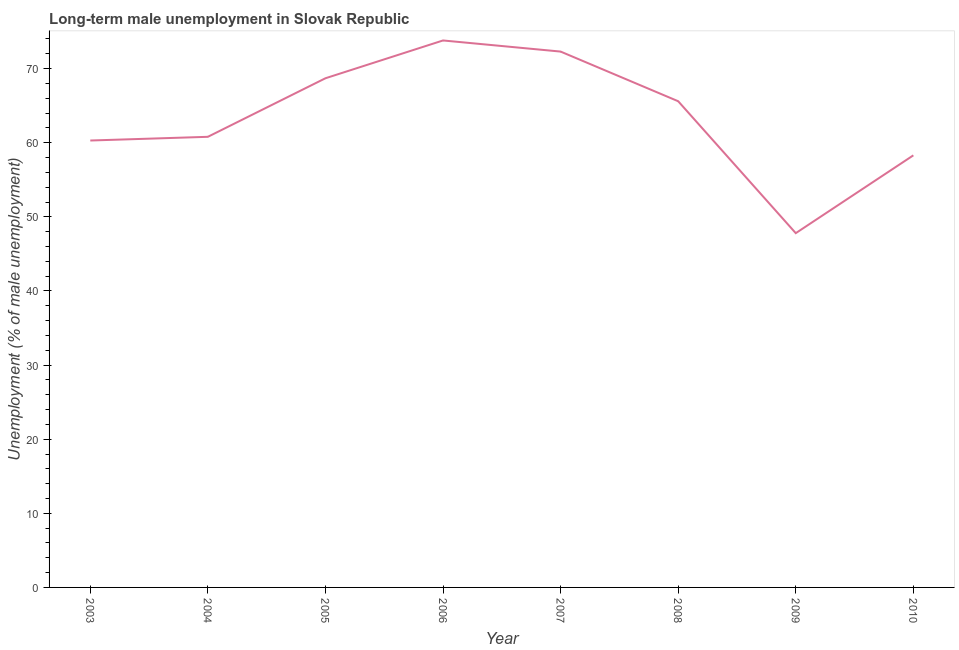What is the long-term male unemployment in 2008?
Provide a short and direct response. 65.6. Across all years, what is the maximum long-term male unemployment?
Provide a succinct answer. 73.8. Across all years, what is the minimum long-term male unemployment?
Your answer should be very brief. 47.8. In which year was the long-term male unemployment maximum?
Your response must be concise. 2006. In which year was the long-term male unemployment minimum?
Provide a short and direct response. 2009. What is the sum of the long-term male unemployment?
Provide a short and direct response. 507.6. What is the difference between the long-term male unemployment in 2004 and 2008?
Your answer should be very brief. -4.8. What is the average long-term male unemployment per year?
Keep it short and to the point. 63.45. What is the median long-term male unemployment?
Your response must be concise. 63.2. What is the ratio of the long-term male unemployment in 2005 to that in 2007?
Ensure brevity in your answer.  0.95. Is the long-term male unemployment in 2008 less than that in 2009?
Your answer should be compact. No. Is the sum of the long-term male unemployment in 2006 and 2008 greater than the maximum long-term male unemployment across all years?
Provide a succinct answer. Yes. What is the difference between the highest and the lowest long-term male unemployment?
Ensure brevity in your answer.  26. In how many years, is the long-term male unemployment greater than the average long-term male unemployment taken over all years?
Provide a short and direct response. 4. How many lines are there?
Your response must be concise. 1. Are the values on the major ticks of Y-axis written in scientific E-notation?
Offer a very short reply. No. What is the title of the graph?
Make the answer very short. Long-term male unemployment in Slovak Republic. What is the label or title of the Y-axis?
Give a very brief answer. Unemployment (% of male unemployment). What is the Unemployment (% of male unemployment) in 2003?
Ensure brevity in your answer.  60.3. What is the Unemployment (% of male unemployment) in 2004?
Your answer should be compact. 60.8. What is the Unemployment (% of male unemployment) in 2005?
Your response must be concise. 68.7. What is the Unemployment (% of male unemployment) in 2006?
Ensure brevity in your answer.  73.8. What is the Unemployment (% of male unemployment) of 2007?
Your answer should be very brief. 72.3. What is the Unemployment (% of male unemployment) of 2008?
Make the answer very short. 65.6. What is the Unemployment (% of male unemployment) of 2009?
Give a very brief answer. 47.8. What is the Unemployment (% of male unemployment) in 2010?
Your answer should be compact. 58.3. What is the difference between the Unemployment (% of male unemployment) in 2003 and 2005?
Provide a short and direct response. -8.4. What is the difference between the Unemployment (% of male unemployment) in 2003 and 2006?
Provide a succinct answer. -13.5. What is the difference between the Unemployment (% of male unemployment) in 2004 and 2005?
Your answer should be very brief. -7.9. What is the difference between the Unemployment (% of male unemployment) in 2004 and 2008?
Your response must be concise. -4.8. What is the difference between the Unemployment (% of male unemployment) in 2004 and 2009?
Keep it short and to the point. 13. What is the difference between the Unemployment (% of male unemployment) in 2005 and 2006?
Offer a very short reply. -5.1. What is the difference between the Unemployment (% of male unemployment) in 2005 and 2007?
Offer a very short reply. -3.6. What is the difference between the Unemployment (% of male unemployment) in 2005 and 2008?
Make the answer very short. 3.1. What is the difference between the Unemployment (% of male unemployment) in 2005 and 2009?
Offer a terse response. 20.9. What is the difference between the Unemployment (% of male unemployment) in 2005 and 2010?
Your response must be concise. 10.4. What is the difference between the Unemployment (% of male unemployment) in 2006 and 2007?
Make the answer very short. 1.5. What is the difference between the Unemployment (% of male unemployment) in 2006 and 2008?
Provide a short and direct response. 8.2. What is the difference between the Unemployment (% of male unemployment) in 2006 and 2010?
Your answer should be compact. 15.5. What is the difference between the Unemployment (% of male unemployment) in 2007 and 2008?
Keep it short and to the point. 6.7. What is the difference between the Unemployment (% of male unemployment) in 2007 and 2010?
Provide a succinct answer. 14. What is the difference between the Unemployment (% of male unemployment) in 2008 and 2010?
Your answer should be compact. 7.3. What is the difference between the Unemployment (% of male unemployment) in 2009 and 2010?
Ensure brevity in your answer.  -10.5. What is the ratio of the Unemployment (% of male unemployment) in 2003 to that in 2005?
Keep it short and to the point. 0.88. What is the ratio of the Unemployment (% of male unemployment) in 2003 to that in 2006?
Make the answer very short. 0.82. What is the ratio of the Unemployment (% of male unemployment) in 2003 to that in 2007?
Make the answer very short. 0.83. What is the ratio of the Unemployment (% of male unemployment) in 2003 to that in 2008?
Provide a short and direct response. 0.92. What is the ratio of the Unemployment (% of male unemployment) in 2003 to that in 2009?
Your answer should be very brief. 1.26. What is the ratio of the Unemployment (% of male unemployment) in 2003 to that in 2010?
Ensure brevity in your answer.  1.03. What is the ratio of the Unemployment (% of male unemployment) in 2004 to that in 2005?
Provide a succinct answer. 0.89. What is the ratio of the Unemployment (% of male unemployment) in 2004 to that in 2006?
Keep it short and to the point. 0.82. What is the ratio of the Unemployment (% of male unemployment) in 2004 to that in 2007?
Your answer should be compact. 0.84. What is the ratio of the Unemployment (% of male unemployment) in 2004 to that in 2008?
Your answer should be compact. 0.93. What is the ratio of the Unemployment (% of male unemployment) in 2004 to that in 2009?
Your response must be concise. 1.27. What is the ratio of the Unemployment (% of male unemployment) in 2004 to that in 2010?
Your response must be concise. 1.04. What is the ratio of the Unemployment (% of male unemployment) in 2005 to that in 2008?
Your answer should be compact. 1.05. What is the ratio of the Unemployment (% of male unemployment) in 2005 to that in 2009?
Give a very brief answer. 1.44. What is the ratio of the Unemployment (% of male unemployment) in 2005 to that in 2010?
Offer a very short reply. 1.18. What is the ratio of the Unemployment (% of male unemployment) in 2006 to that in 2007?
Keep it short and to the point. 1.02. What is the ratio of the Unemployment (% of male unemployment) in 2006 to that in 2009?
Provide a short and direct response. 1.54. What is the ratio of the Unemployment (% of male unemployment) in 2006 to that in 2010?
Make the answer very short. 1.27. What is the ratio of the Unemployment (% of male unemployment) in 2007 to that in 2008?
Offer a very short reply. 1.1. What is the ratio of the Unemployment (% of male unemployment) in 2007 to that in 2009?
Offer a very short reply. 1.51. What is the ratio of the Unemployment (% of male unemployment) in 2007 to that in 2010?
Give a very brief answer. 1.24. What is the ratio of the Unemployment (% of male unemployment) in 2008 to that in 2009?
Ensure brevity in your answer.  1.37. What is the ratio of the Unemployment (% of male unemployment) in 2009 to that in 2010?
Give a very brief answer. 0.82. 